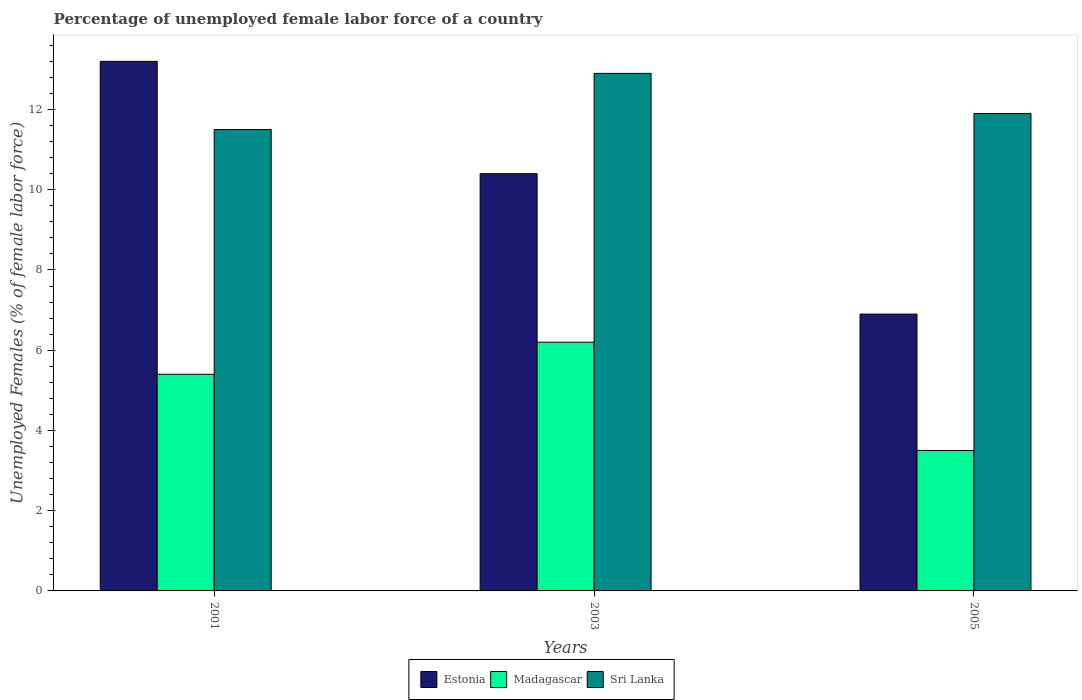Are the number of bars per tick equal to the number of legend labels?
Give a very brief answer. Yes. Are the number of bars on each tick of the X-axis equal?
Offer a very short reply. Yes. How many bars are there on the 2nd tick from the left?
Make the answer very short. 3. What is the percentage of unemployed female labor force in Madagascar in 2003?
Ensure brevity in your answer.  6.2. Across all years, what is the maximum percentage of unemployed female labor force in Estonia?
Offer a terse response. 13.2. Across all years, what is the minimum percentage of unemployed female labor force in Sri Lanka?
Make the answer very short. 11.5. In which year was the percentage of unemployed female labor force in Sri Lanka maximum?
Provide a succinct answer. 2003. What is the total percentage of unemployed female labor force in Estonia in the graph?
Make the answer very short. 30.5. What is the difference between the percentage of unemployed female labor force in Estonia in 2003 and that in 2005?
Your response must be concise. 3.5. What is the difference between the percentage of unemployed female labor force in Madagascar in 2003 and the percentage of unemployed female labor force in Sri Lanka in 2001?
Offer a terse response. -5.3. What is the average percentage of unemployed female labor force in Sri Lanka per year?
Provide a succinct answer. 12.1. In the year 2001, what is the difference between the percentage of unemployed female labor force in Sri Lanka and percentage of unemployed female labor force in Madagascar?
Make the answer very short. 6.1. What is the ratio of the percentage of unemployed female labor force in Madagascar in 2001 to that in 2005?
Offer a terse response. 1.54. Is the percentage of unemployed female labor force in Madagascar in 2001 less than that in 2003?
Your answer should be compact. Yes. Is the difference between the percentage of unemployed female labor force in Sri Lanka in 2003 and 2005 greater than the difference between the percentage of unemployed female labor force in Madagascar in 2003 and 2005?
Make the answer very short. No. What is the difference between the highest and the second highest percentage of unemployed female labor force in Estonia?
Make the answer very short. 2.8. What is the difference between the highest and the lowest percentage of unemployed female labor force in Estonia?
Keep it short and to the point. 6.3. Is the sum of the percentage of unemployed female labor force in Sri Lanka in 2001 and 2005 greater than the maximum percentage of unemployed female labor force in Estonia across all years?
Offer a terse response. Yes. What does the 3rd bar from the left in 2003 represents?
Your answer should be compact. Sri Lanka. What does the 1st bar from the right in 2003 represents?
Make the answer very short. Sri Lanka. How many years are there in the graph?
Give a very brief answer. 3. What is the difference between two consecutive major ticks on the Y-axis?
Make the answer very short. 2. Are the values on the major ticks of Y-axis written in scientific E-notation?
Your answer should be very brief. No. Does the graph contain any zero values?
Provide a succinct answer. No. How many legend labels are there?
Offer a terse response. 3. How are the legend labels stacked?
Offer a terse response. Horizontal. What is the title of the graph?
Offer a terse response. Percentage of unemployed female labor force of a country. What is the label or title of the X-axis?
Your answer should be very brief. Years. What is the label or title of the Y-axis?
Your response must be concise. Unemployed Females (% of female labor force). What is the Unemployed Females (% of female labor force) in Estonia in 2001?
Offer a terse response. 13.2. What is the Unemployed Females (% of female labor force) in Madagascar in 2001?
Ensure brevity in your answer.  5.4. What is the Unemployed Females (% of female labor force) of Sri Lanka in 2001?
Your response must be concise. 11.5. What is the Unemployed Females (% of female labor force) of Estonia in 2003?
Provide a short and direct response. 10.4. What is the Unemployed Females (% of female labor force) of Madagascar in 2003?
Provide a succinct answer. 6.2. What is the Unemployed Females (% of female labor force) of Sri Lanka in 2003?
Make the answer very short. 12.9. What is the Unemployed Females (% of female labor force) of Estonia in 2005?
Your answer should be very brief. 6.9. What is the Unemployed Females (% of female labor force) in Madagascar in 2005?
Your response must be concise. 3.5. What is the Unemployed Females (% of female labor force) of Sri Lanka in 2005?
Ensure brevity in your answer.  11.9. Across all years, what is the maximum Unemployed Females (% of female labor force) in Estonia?
Provide a succinct answer. 13.2. Across all years, what is the maximum Unemployed Females (% of female labor force) in Madagascar?
Provide a succinct answer. 6.2. Across all years, what is the maximum Unemployed Females (% of female labor force) of Sri Lanka?
Make the answer very short. 12.9. Across all years, what is the minimum Unemployed Females (% of female labor force) in Estonia?
Offer a terse response. 6.9. Across all years, what is the minimum Unemployed Females (% of female labor force) in Madagascar?
Provide a succinct answer. 3.5. What is the total Unemployed Females (% of female labor force) in Estonia in the graph?
Your answer should be compact. 30.5. What is the total Unemployed Females (% of female labor force) in Sri Lanka in the graph?
Keep it short and to the point. 36.3. What is the difference between the Unemployed Females (% of female labor force) of Estonia in 2001 and that in 2003?
Give a very brief answer. 2.8. What is the difference between the Unemployed Females (% of female labor force) in Madagascar in 2001 and that in 2003?
Offer a terse response. -0.8. What is the difference between the Unemployed Females (% of female labor force) in Sri Lanka in 2001 and that in 2003?
Ensure brevity in your answer.  -1.4. What is the difference between the Unemployed Females (% of female labor force) in Estonia in 2001 and that in 2005?
Your response must be concise. 6.3. What is the difference between the Unemployed Females (% of female labor force) of Madagascar in 2001 and that in 2005?
Provide a succinct answer. 1.9. What is the difference between the Unemployed Females (% of female labor force) in Sri Lanka in 2001 and that in 2005?
Your response must be concise. -0.4. What is the difference between the Unemployed Females (% of female labor force) in Madagascar in 2003 and that in 2005?
Offer a very short reply. 2.7. What is the difference between the Unemployed Females (% of female labor force) of Estonia in 2001 and the Unemployed Females (% of female labor force) of Madagascar in 2003?
Your answer should be compact. 7. What is the difference between the Unemployed Females (% of female labor force) in Estonia in 2001 and the Unemployed Females (% of female labor force) in Sri Lanka in 2003?
Offer a terse response. 0.3. What is the difference between the Unemployed Females (% of female labor force) of Madagascar in 2001 and the Unemployed Females (% of female labor force) of Sri Lanka in 2003?
Provide a succinct answer. -7.5. What is the difference between the Unemployed Females (% of female labor force) of Estonia in 2001 and the Unemployed Females (% of female labor force) of Sri Lanka in 2005?
Keep it short and to the point. 1.3. What is the difference between the Unemployed Females (% of female labor force) in Estonia in 2003 and the Unemployed Females (% of female labor force) in Madagascar in 2005?
Provide a succinct answer. 6.9. What is the difference between the Unemployed Females (% of female labor force) in Madagascar in 2003 and the Unemployed Females (% of female labor force) in Sri Lanka in 2005?
Your answer should be compact. -5.7. What is the average Unemployed Females (% of female labor force) of Estonia per year?
Your response must be concise. 10.17. What is the average Unemployed Females (% of female labor force) of Madagascar per year?
Provide a succinct answer. 5.03. What is the average Unemployed Females (% of female labor force) of Sri Lanka per year?
Provide a short and direct response. 12.1. In the year 2001, what is the difference between the Unemployed Females (% of female labor force) in Estonia and Unemployed Females (% of female labor force) in Madagascar?
Your answer should be very brief. 7.8. In the year 2001, what is the difference between the Unemployed Females (% of female labor force) of Estonia and Unemployed Females (% of female labor force) of Sri Lanka?
Keep it short and to the point. 1.7. In the year 2001, what is the difference between the Unemployed Females (% of female labor force) in Madagascar and Unemployed Females (% of female labor force) in Sri Lanka?
Keep it short and to the point. -6.1. In the year 2003, what is the difference between the Unemployed Females (% of female labor force) in Estonia and Unemployed Females (% of female labor force) in Madagascar?
Your answer should be compact. 4.2. In the year 2003, what is the difference between the Unemployed Females (% of female labor force) in Madagascar and Unemployed Females (% of female labor force) in Sri Lanka?
Provide a short and direct response. -6.7. In the year 2005, what is the difference between the Unemployed Females (% of female labor force) of Estonia and Unemployed Females (% of female labor force) of Madagascar?
Keep it short and to the point. 3.4. In the year 2005, what is the difference between the Unemployed Females (% of female labor force) of Estonia and Unemployed Females (% of female labor force) of Sri Lanka?
Provide a succinct answer. -5. What is the ratio of the Unemployed Females (% of female labor force) of Estonia in 2001 to that in 2003?
Provide a short and direct response. 1.27. What is the ratio of the Unemployed Females (% of female labor force) of Madagascar in 2001 to that in 2003?
Your response must be concise. 0.87. What is the ratio of the Unemployed Females (% of female labor force) in Sri Lanka in 2001 to that in 2003?
Provide a short and direct response. 0.89. What is the ratio of the Unemployed Females (% of female labor force) of Estonia in 2001 to that in 2005?
Offer a very short reply. 1.91. What is the ratio of the Unemployed Females (% of female labor force) in Madagascar in 2001 to that in 2005?
Provide a short and direct response. 1.54. What is the ratio of the Unemployed Females (% of female labor force) in Sri Lanka in 2001 to that in 2005?
Offer a terse response. 0.97. What is the ratio of the Unemployed Females (% of female labor force) in Estonia in 2003 to that in 2005?
Provide a succinct answer. 1.51. What is the ratio of the Unemployed Females (% of female labor force) in Madagascar in 2003 to that in 2005?
Your response must be concise. 1.77. What is the ratio of the Unemployed Females (% of female labor force) in Sri Lanka in 2003 to that in 2005?
Provide a short and direct response. 1.08. What is the difference between the highest and the second highest Unemployed Females (% of female labor force) in Estonia?
Keep it short and to the point. 2.8. What is the difference between the highest and the second highest Unemployed Females (% of female labor force) of Madagascar?
Ensure brevity in your answer.  0.8. What is the difference between the highest and the lowest Unemployed Females (% of female labor force) of Madagascar?
Keep it short and to the point. 2.7. 